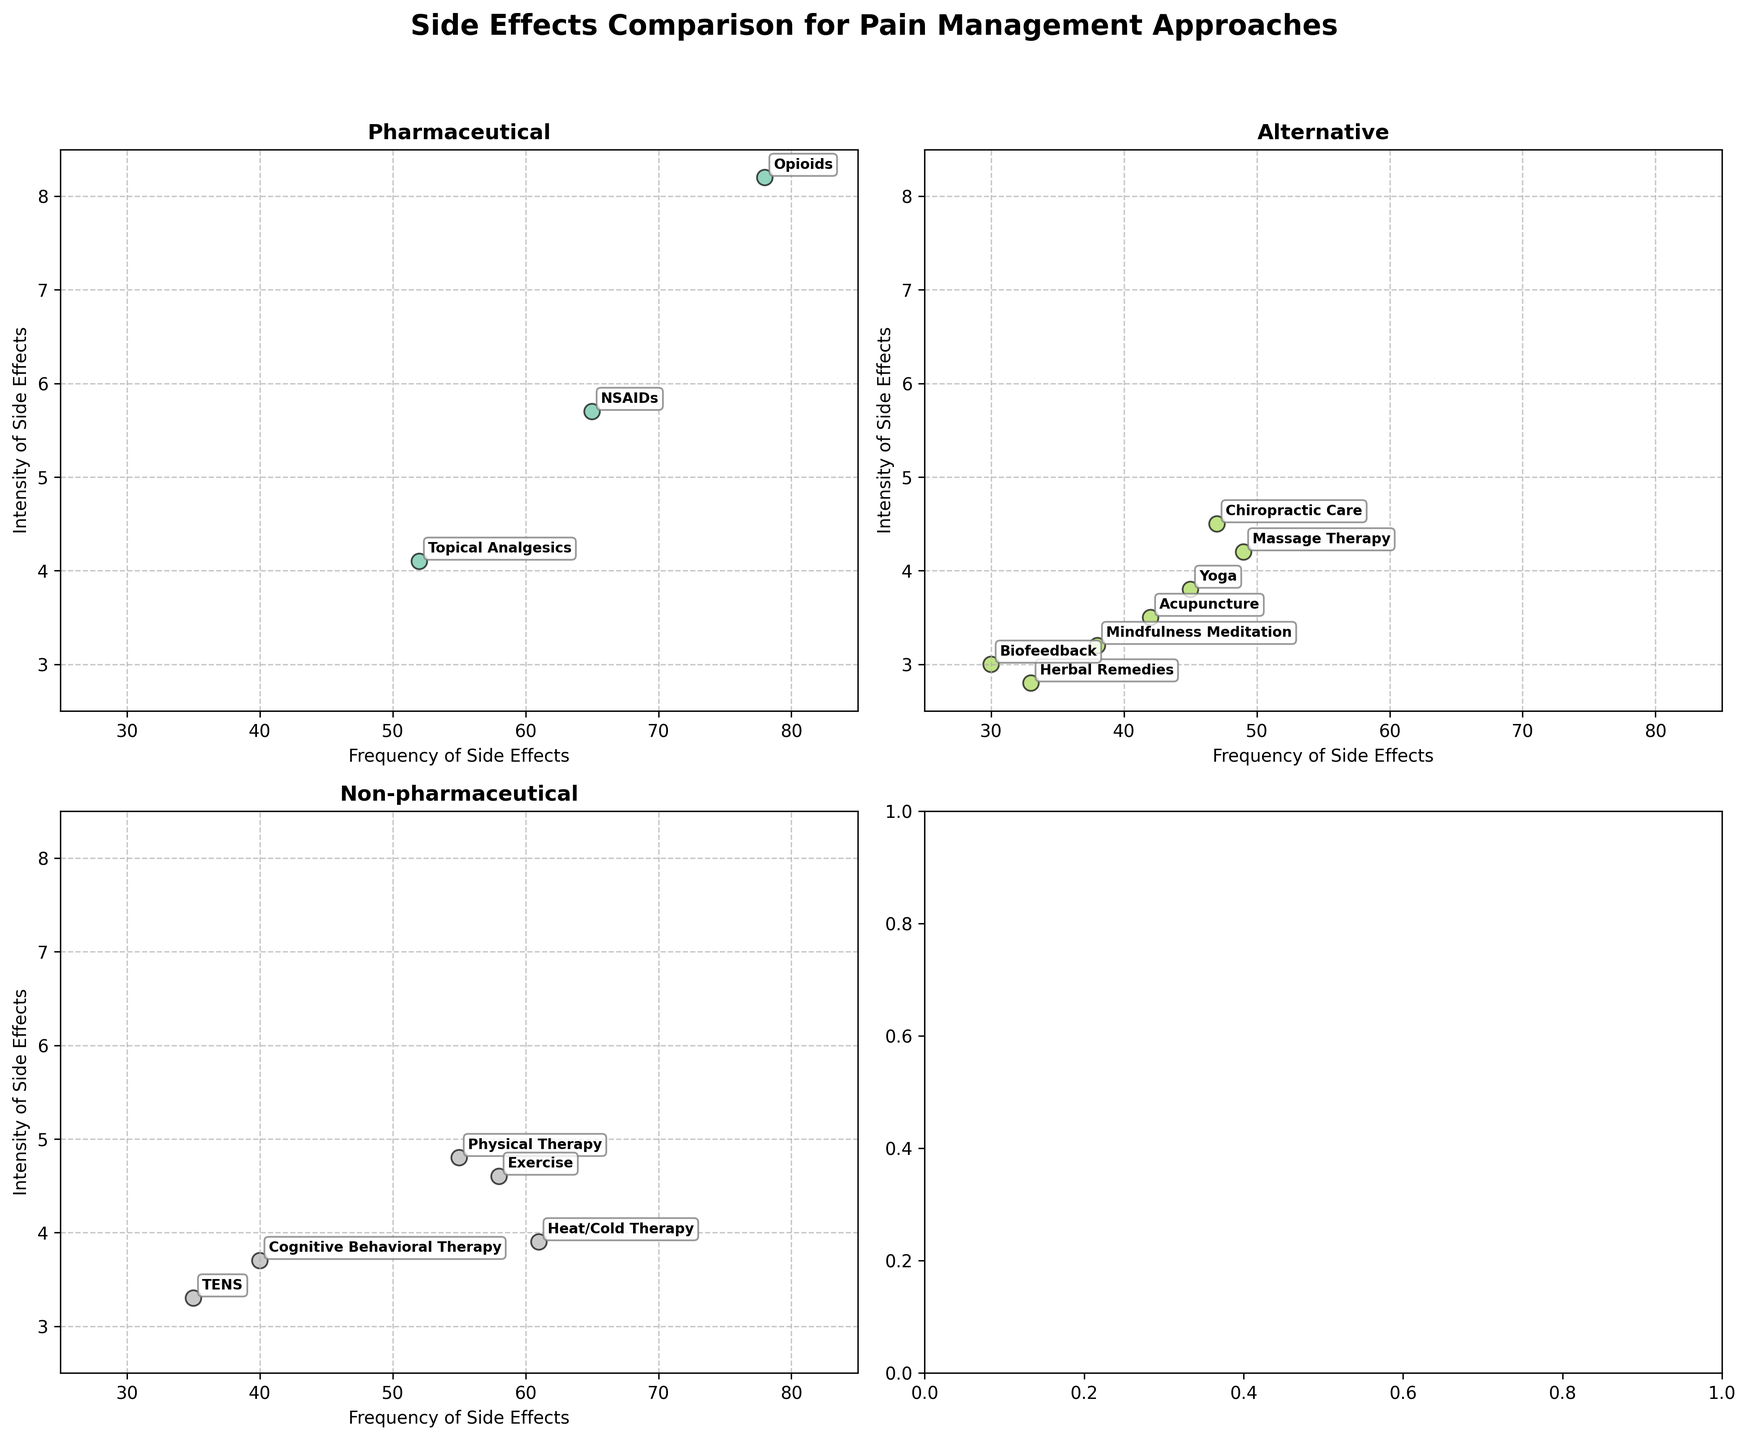What's the title of the figure? The title is located at the top center of the figure. By directly reading it, we can determine the title is "Side Effects Comparison for Pain Management Approaches".
Answer: Side Effects Comparison for Pain Management Approaches Which category contains the treatment with the highest frequency of side effects? By looking at each subplot, we find the highest frequency value. The highest frequency is 78, which corresponds to "Opioids" in the "Pharmaceutical" category.
Answer: Pharmaceutical What is the range of frequency values displayed on the x-axis? The x-axis of each subplot ranges from 25 to 85, as this is the limit set for the x-axis.
Answer: 25 to 85 How many treatments are there in the Alternative category? Counting the labels in the Alternative category subplot reveals there are 6 treatments.
Answer: 6 Which treatment has the highest intensity of side effects, and what is its value? The highest intensity data point can be identified in the subplots. Opioids, under Pharmaceutical, has the highest intensity value of 8.2.
Answer: Opioids, 8.2 Compare the frequency and intensity of side effects between Acupuncture and Massage Therapy. Which one has higher values? By locating both treatments in the Alternative category subplot, we see Acupuncture has a frequency of 42 and intensity of 3.5, while Massage Therapy has a frequency of 49 and intensity of 4.2. Thus, Massage Therapy has higher values.
Answer: Massage Therapy What is the average intensity of side effects for treatments in the Non-pharmaceutical category? The intensities in the Non-pharmaceutical category are 4.8, 3.9, 3.3, 3.7, and 4.6. The average is calculated as: (4.8 + 3.9 + 3.3 + 3.7 + 4.6) / 5 = 20.3 / 5 = 4.06.
Answer: 4.06 Are there any treatments in the Alternative category with both frequency and intensity lower than 40 and 3.5 respectively? Checking the Alternative subplot, Herbal Remedies has frequency 33 and intensity 2.8, which are both below 40 and 3.5.
Answer: Herbal Remedies Which treatment has a lower frequency of side effects: Chiropractic Care or Physical Therapy? Comparing the frequencies in the respective subplots, Physical Therapy has a frequency of 55, while Chiropractic Care has a frequency of 47.
Answer: Chiropractic Care What is the intensity range (difference between highest and lowest values) in the Pharmaceutical category? The highest intensity in Pharmaceutical is 8.2 (Opioids) and the lowest is 4.1 (Topical Analgesics). The range is calculated as: 8.2 - 4.1 = 4.1.
Answer: 4.1 